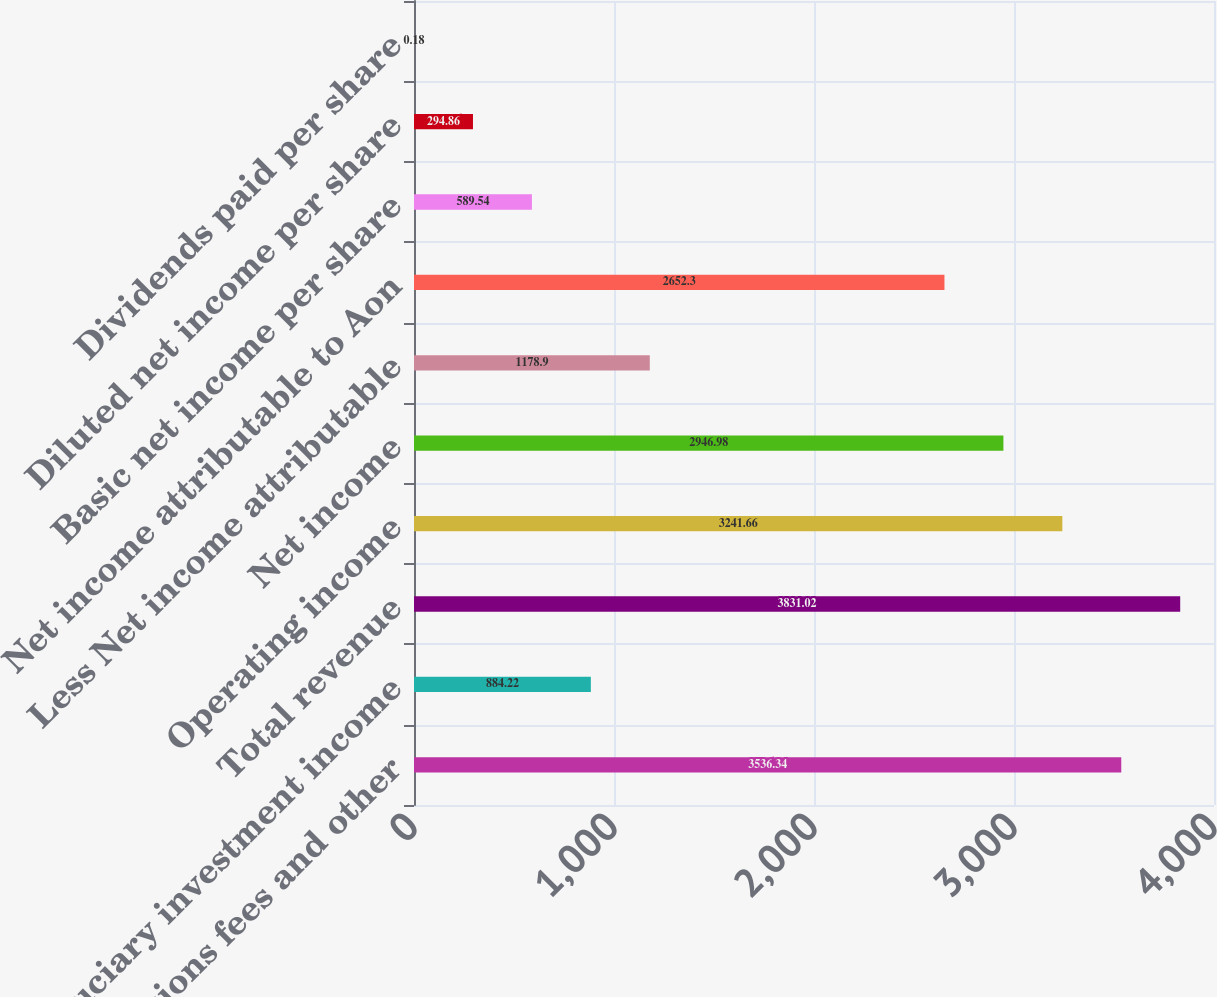Convert chart. <chart><loc_0><loc_0><loc_500><loc_500><bar_chart><fcel>Commissions fees and other<fcel>Fiduciary investment income<fcel>Total revenue<fcel>Operating income<fcel>Net income<fcel>Less Net income attributable<fcel>Net income attributable to Aon<fcel>Basic net income per share<fcel>Diluted net income per share<fcel>Dividends paid per share<nl><fcel>3536.34<fcel>884.22<fcel>3831.02<fcel>3241.66<fcel>2946.98<fcel>1178.9<fcel>2652.3<fcel>589.54<fcel>294.86<fcel>0.18<nl></chart> 